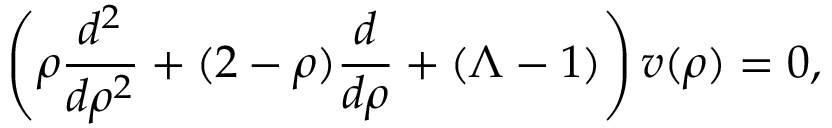Convert formula to latex. <formula><loc_0><loc_0><loc_500><loc_500>\left ( \rho \frac { d ^ { 2 } } { d \rho ^ { 2 } } + ( 2 - \rho ) \frac { d } { d \rho } + ( \Lambda - 1 ) \right ) v ( \rho ) = 0 ,</formula> 